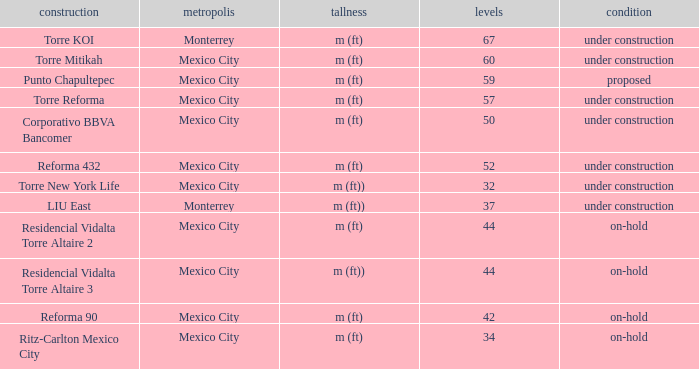How many stories is the torre reforma building? 1.0. 